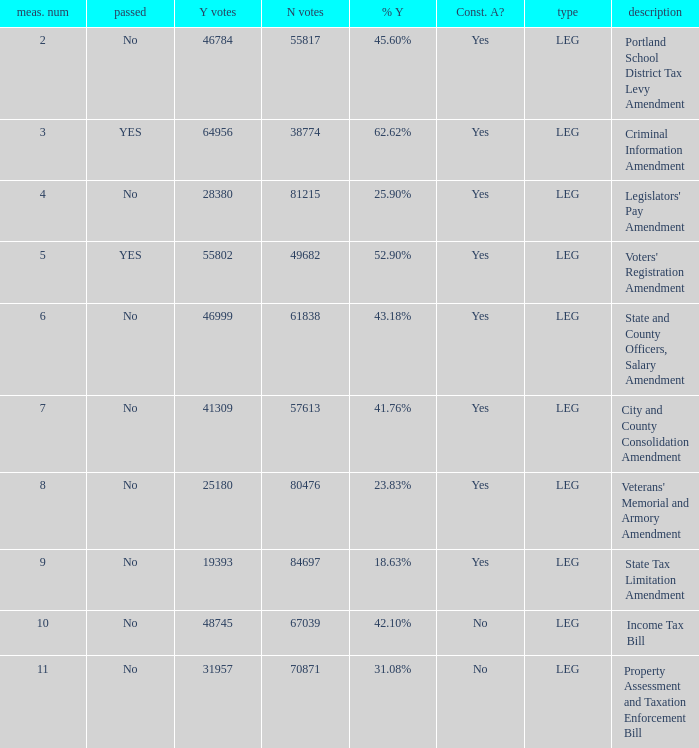Who had 41.76% yes votes City and County Consolidation Amendment. 